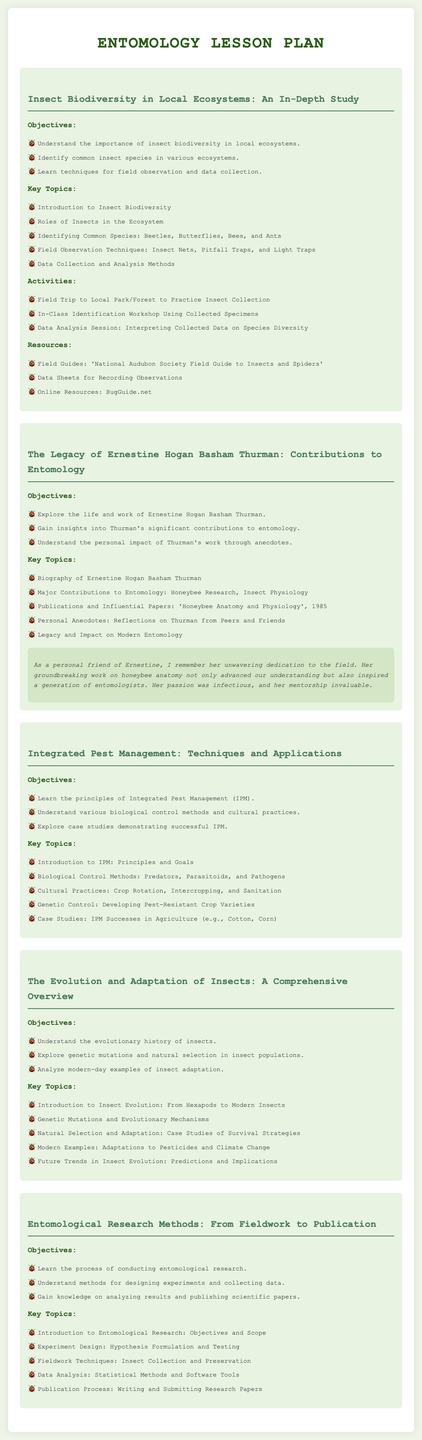What are the key objectives of the lesson on insect biodiversity? The objectives are outlined in the lesson plan and include understanding the importance of insect biodiversity, identifying common species, and learning techniques for field observation.
Answer: Understand the importance of insect biodiversity in local ecosystems, Identify common insect species in various ecosystems, Learn techniques for field observation and data collection Who is the focus of the lesson titled "The Legacy of Ernestine Hogan Basham Thurman"? The lesson plan specifies that it explores the life and contributions of Ernestine Hogan Basham Thurman, highlighting her significant work in entomology.
Answer: Ernestine Hogan Basham Thurman What is one of the resources listed for the insect biodiversity lesson? Resources for the lesson include field guides and online resources, specifically mentioning a notable field guide in the document.
Answer: National Audubon Society Field Guide to Insects and Spiders What is a key topic covered in the Integrated Pest Management lesson? The lesson plan details various topics, one of which is biological control methods, encompassing predators, parasitoids, and pathogens as part of the IPM.
Answer: Biological Control Methods: Predators, Parasitoids, and Pathogens What personal note is included in the section about Ernestine Hogan Basham Thurman? The personal note reflects on the dedication of Ernestine and her impact on the field, sharing a memorable sentiment about her mentorship and passion for entomology.
Answer: Her groundbreaking work on honeybee anatomy not only advanced our understanding but also inspired a generation of entomologists How many key topics are listed under the lesson on the evolution and adaptation of insects? The lesson plan enumerates the key topics covered in this section, providing insights into the evolutionary history and adaptations of insects.
Answer: Five 